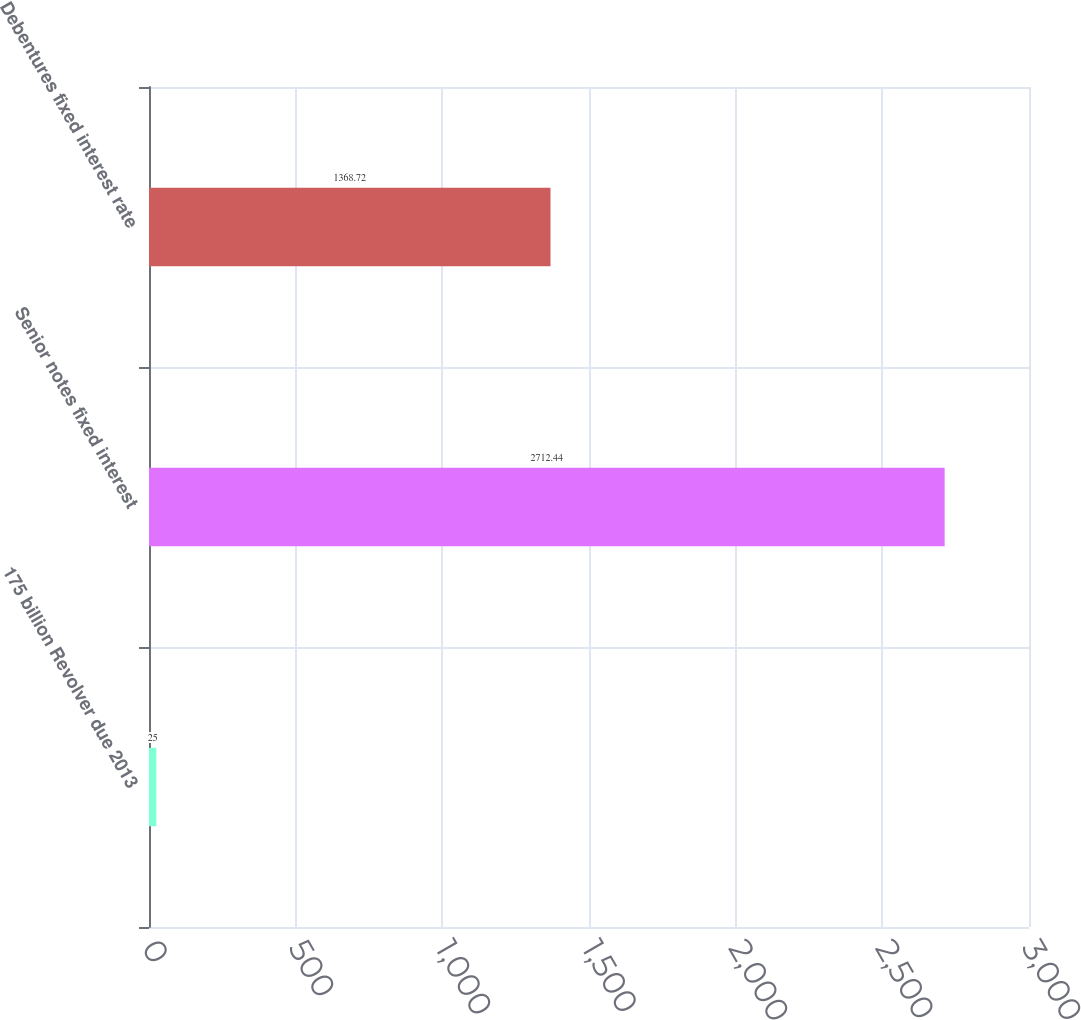Convert chart. <chart><loc_0><loc_0><loc_500><loc_500><bar_chart><fcel>175 billion Revolver due 2013<fcel>Senior notes fixed interest<fcel>Debentures fixed interest rate<nl><fcel>25<fcel>2712.44<fcel>1368.72<nl></chart> 